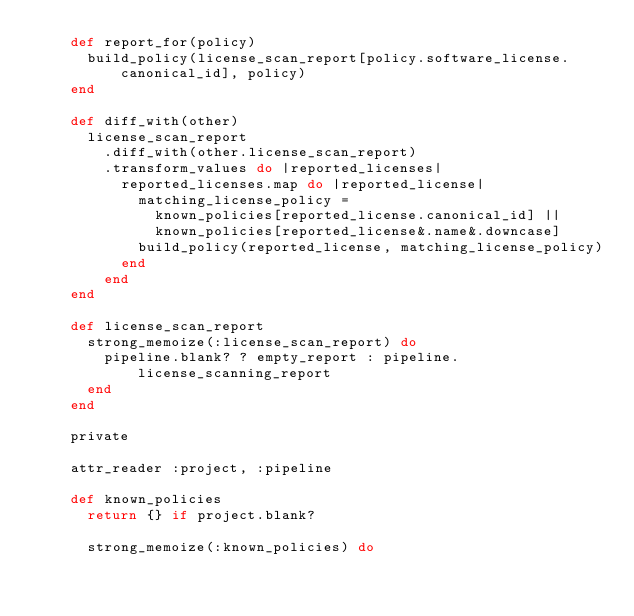Convert code to text. <code><loc_0><loc_0><loc_500><loc_500><_Ruby_>    def report_for(policy)
      build_policy(license_scan_report[policy.software_license.canonical_id], policy)
    end

    def diff_with(other)
      license_scan_report
        .diff_with(other.license_scan_report)
        .transform_values do |reported_licenses|
          reported_licenses.map do |reported_license|
            matching_license_policy =
              known_policies[reported_license.canonical_id] ||
              known_policies[reported_license&.name&.downcase]
            build_policy(reported_license, matching_license_policy)
          end
        end
    end

    def license_scan_report
      strong_memoize(:license_scan_report) do
        pipeline.blank? ? empty_report : pipeline.license_scanning_report
      end
    end

    private

    attr_reader :project, :pipeline

    def known_policies
      return {} if project.blank?

      strong_memoize(:known_policies) do</code> 